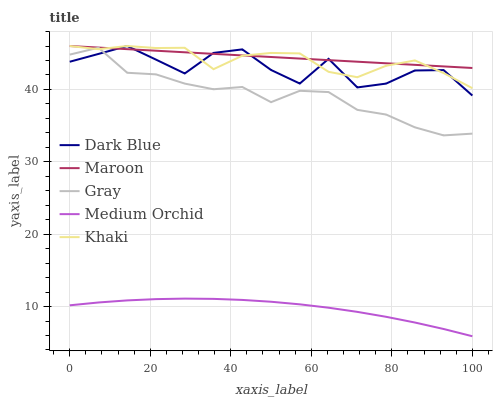Does Khaki have the minimum area under the curve?
Answer yes or no. No. Does Khaki have the maximum area under the curve?
Answer yes or no. No. Is Medium Orchid the smoothest?
Answer yes or no. No. Is Medium Orchid the roughest?
Answer yes or no. No. Does Khaki have the lowest value?
Answer yes or no. No. Does Medium Orchid have the highest value?
Answer yes or no. No. Is Medium Orchid less than Khaki?
Answer yes or no. Yes. Is Maroon greater than Medium Orchid?
Answer yes or no. Yes. Does Medium Orchid intersect Khaki?
Answer yes or no. No. 